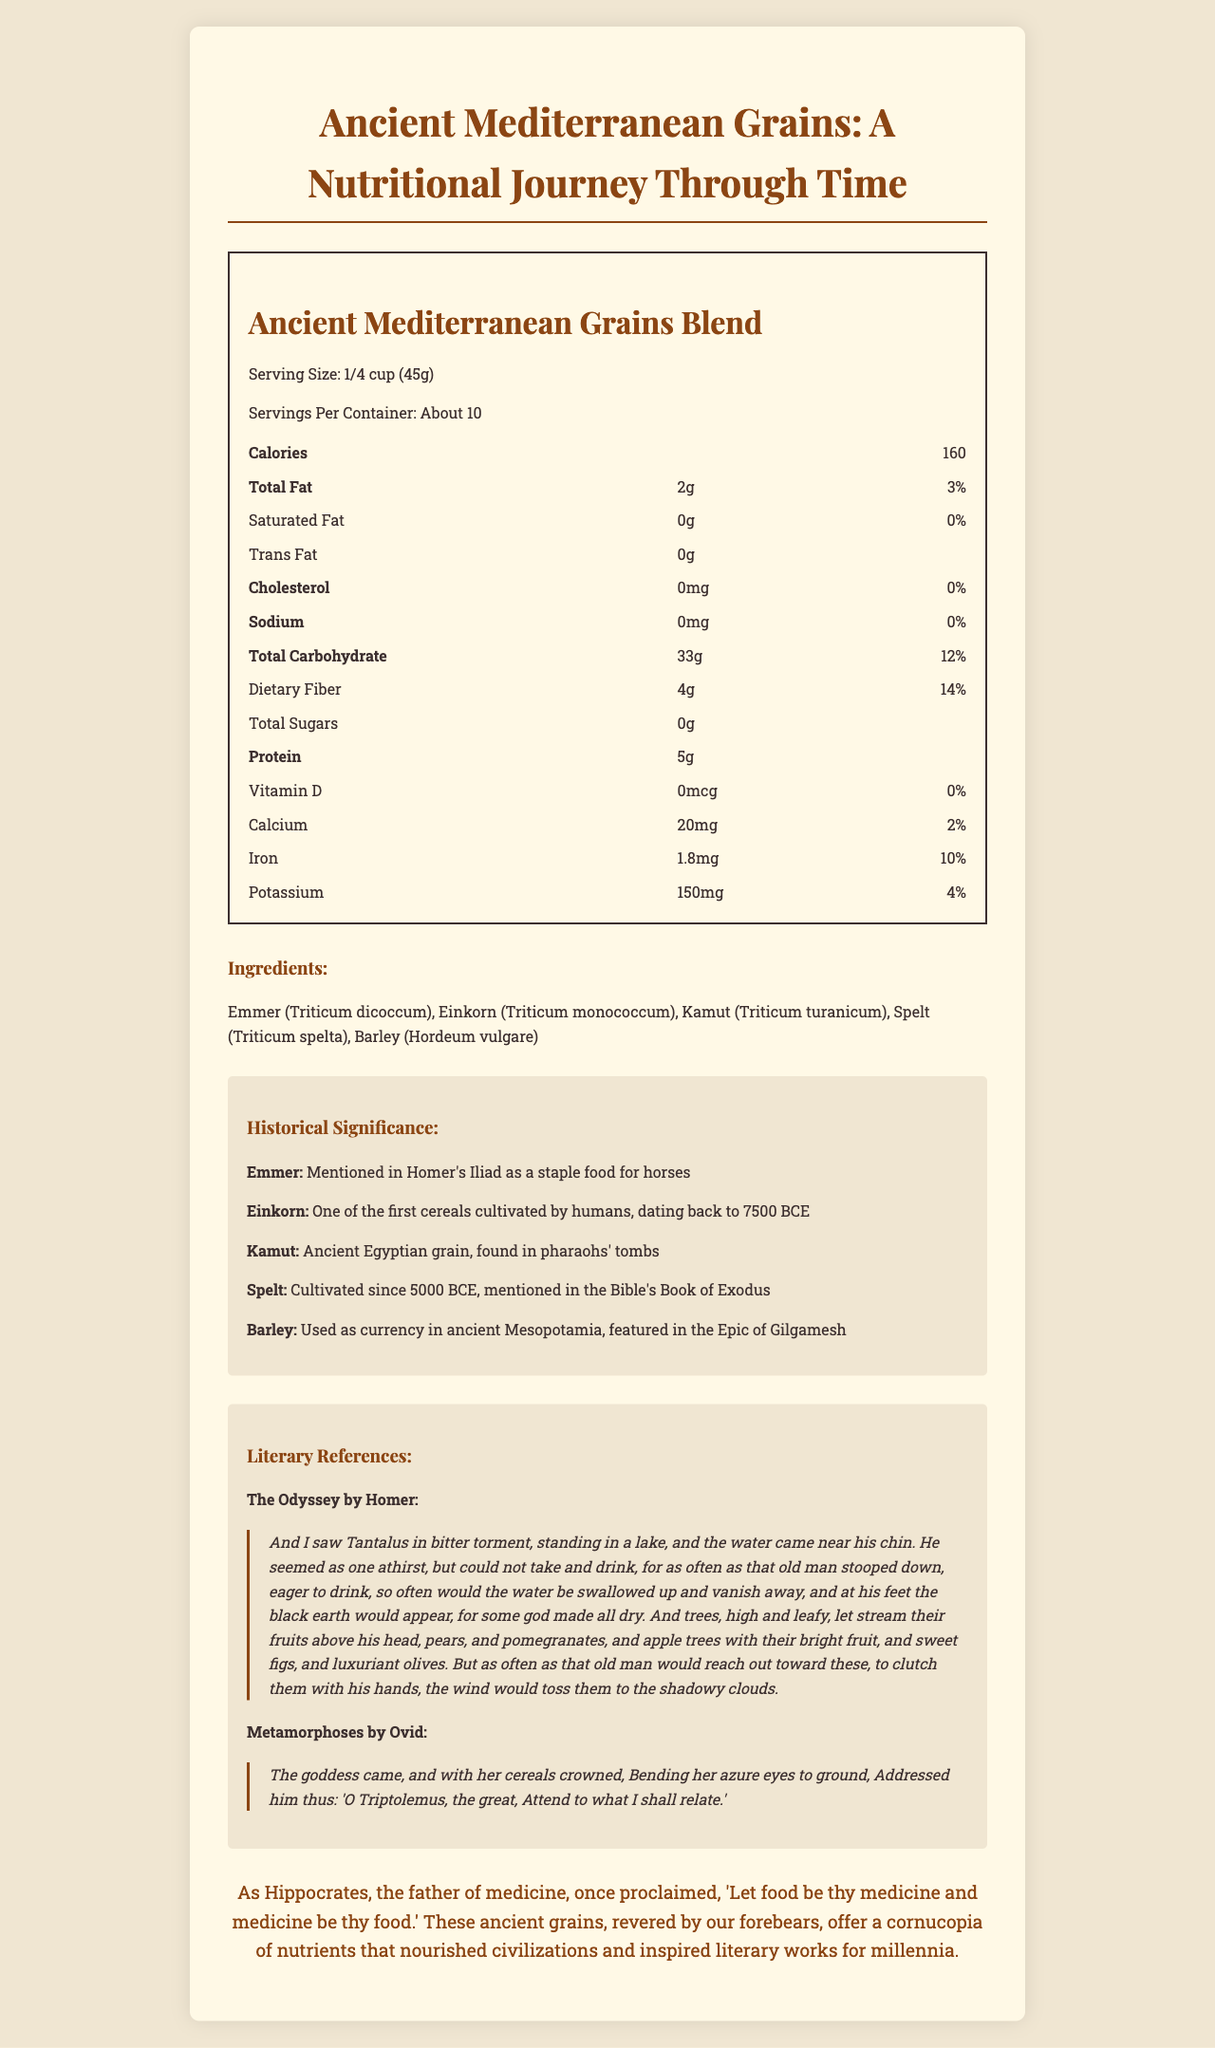what is the serving size of the product? The serving size is clearly stated in the Nutrition Facts section of the document.
Answer: 1/4 cup (45g) How many servings does the container have? The document states that there are about 10 servings per container.
Answer: About 10 What is the total fat content per serving? The total fat content is listed under the Nutrition Facts section as 2g per serving.
Answer: 2g How much dietary fiber is in each serving? The dietary fiber content per serving is listed as 4g in the Nutrition Facts section.
Answer: 4g What historical significance does Emmer have? The historical significance of Emmer is mentioned under the Historical Significance section.
Answer: Mentioned in Homer's Iliad as a staple food for horses Which grain was found in pharaohs' tombs? The document states that Kamut was an ancient Egyptian grain found in pharaohs' tombs.
Answer: Kamut What percentage of the daily value of iron does one serving provide? The percentage daily value of iron is listed as 10% per serving in the Nutrition Facts section.
Answer: 10% Which ancient grain is mentioned in the Bible's Book of Exodus? The historical significance section mentions that Spelt is cultivated since 5000 BCE and mentioned in the Bible's Book of Exodus.
Answer: Spelt How much protein does one serving contain? The protein content per serving is listed as 5g in the Nutrition Facts section.
Answer: 5g What vitamin has 0% daily value in this product? The daily value of Vitamin D is listed as 0% in the Nutrition Facts section.
Answer: Vitamin D Identify two works of classical literature that reference grains. A. The Iliad, The Odyssey B. The Aeneid, Metamorphoses C. The Odyssey, Metamorphoses D. The Iliad, The Aeneid The literary references include quotes from The Odyssey by Homer and Metamorphoses by Ovid, mentioning grains.
Answer: C. The Odyssey, Metamorphoses Which of the following grains were used as currency in ancient Mesopotamia? I. Emmer II. Barley III. Spelt IV. Einkorn The historical significance section mentions that Barley was used as currency in ancient Mesopotamia.
Answer: II. Barley Is there any cholesterol in this grains blend? The Nutrition Facts section lists the cholesterol content as 0mg, which means there is no cholesterol in this product.
Answer: No Summarize the main idea of the document. The document covers various nutritional aspects of the grains blend, mentions its historical and literary importance, and quotes relevant classical literature, showcasing the significance of these grains in ancient civilizations and their enduring impact.
Answer: The document provides detailed nutritional information for an Ancient Mediterranean Grains Blend, including serving size, calorie count, and nutrient content. Additionally, it highlights the historical significance and literary references of the included grains, emphasizing their cultural and nutritional value through history. What is the recommended daily value percentage of potassium provided by one serving of this product? The Nutrition Facts section lists the daily value percentage for potassium as 4%.
Answer: 4% How many grams of total carbohydrates does one serving contain? The document lists the total carbohydrate content per serving as 33g under the Nutrition Facts section.
Answer: 33g Which famous phrase by Hippocrates is included in the document? The document includes the quote by Hippocrates in the "nutritional wisdom" section, highlighting the importance of food as a source of medicine.
Answer: "Let food be thy medicine and medicine be thy food." Is there enough information in the document to determine the glycemic index of the grains blend? The document provides detailed nutritional information but does not mention the glycemic index of the grains blend itself.
Answer: Not enough information 